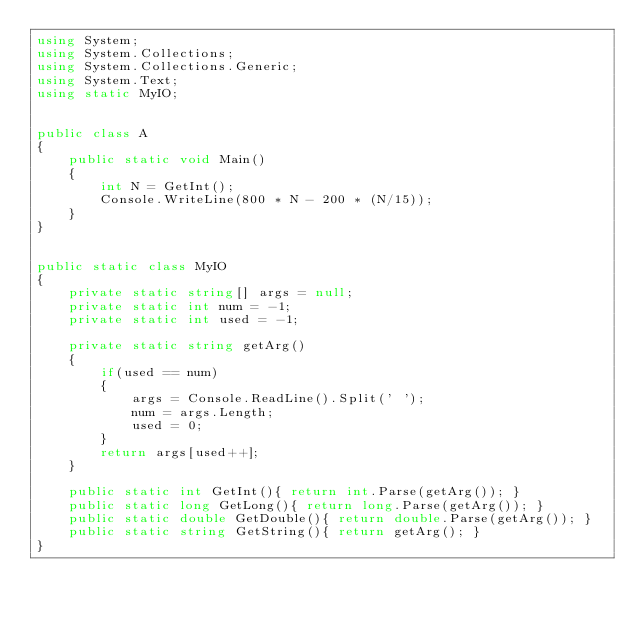Convert code to text. <code><loc_0><loc_0><loc_500><loc_500><_C#_>using System;
using System.Collections;
using System.Collections.Generic;
using System.Text;
using static MyIO;


public class A
{
	public static void Main()
	{
		int N = GetInt();		
		Console.WriteLine(800 * N - 200 * (N/15));
	}
}


public static class MyIO
{
	private static string[] args = null;
	private static int num = -1;
	private static int used = -1;

	private static string getArg()
	{
		if(used == num)
		{
			args = Console.ReadLine().Split(' ');
			num = args.Length;
			used = 0;
		}
		return args[used++];
	}

	public static int GetInt(){ return int.Parse(getArg()); }
	public static long GetLong(){ return long.Parse(getArg()); }
	public static double GetDouble(){ return double.Parse(getArg()); }
	public static string GetString(){ return getArg(); }
}</code> 